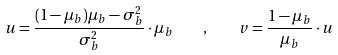<formula> <loc_0><loc_0><loc_500><loc_500>u = \frac { ( 1 - \mu _ { b } ) \mu _ { b } - \sigma _ { b } ^ { 2 } } { \sigma _ { b } ^ { 2 } } \cdot \mu _ { b } \quad , \quad v = \frac { 1 - \mu _ { b } } { \mu _ { b } } \cdot u</formula> 